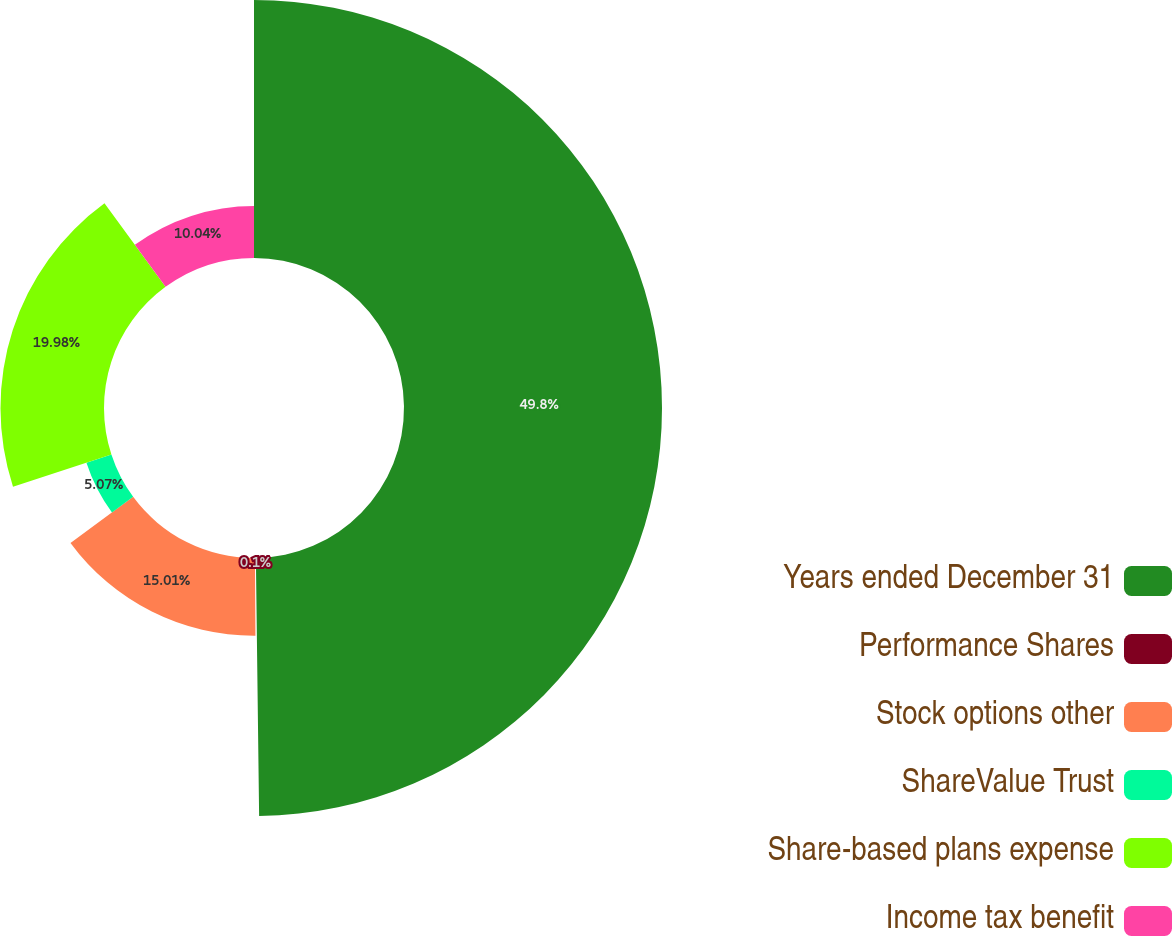Convert chart to OTSL. <chart><loc_0><loc_0><loc_500><loc_500><pie_chart><fcel>Years ended December 31<fcel>Performance Shares<fcel>Stock options other<fcel>ShareValue Trust<fcel>Share-based plans expense<fcel>Income tax benefit<nl><fcel>49.8%<fcel>0.1%<fcel>15.01%<fcel>5.07%<fcel>19.98%<fcel>10.04%<nl></chart> 